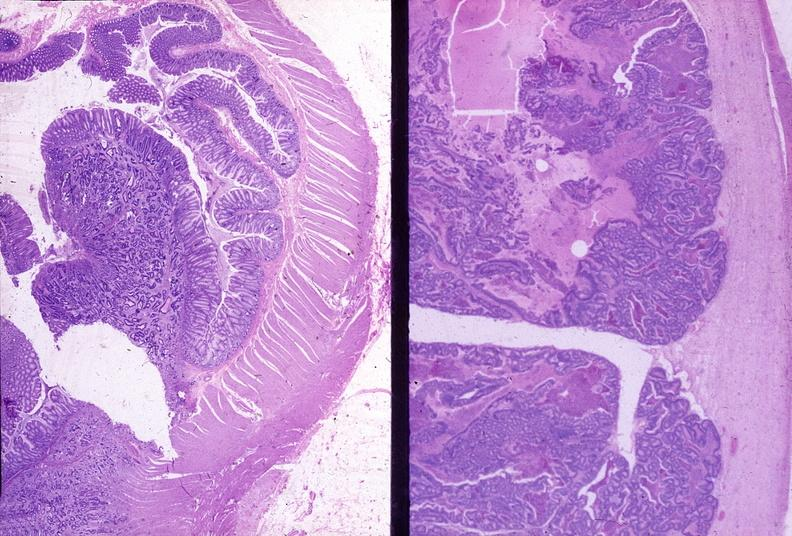s gastrointestinal present?
Answer the question using a single word or phrase. Yes 